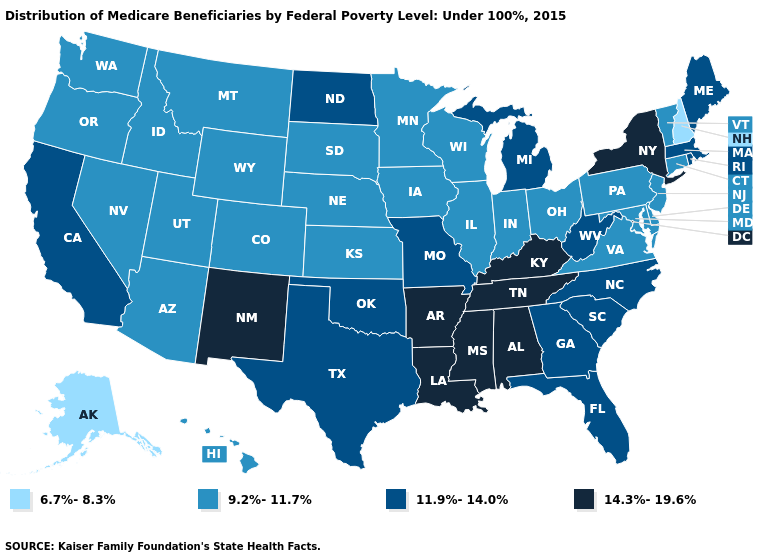What is the highest value in the Northeast ?
Quick response, please. 14.3%-19.6%. What is the lowest value in the MidWest?
Answer briefly. 9.2%-11.7%. Does New York have the highest value in the Northeast?
Short answer required. Yes. Does Michigan have a lower value than New Jersey?
Keep it brief. No. What is the value of Oregon?
Write a very short answer. 9.2%-11.7%. Name the states that have a value in the range 6.7%-8.3%?
Concise answer only. Alaska, New Hampshire. Among the states that border Ohio , which have the lowest value?
Concise answer only. Indiana, Pennsylvania. Does the map have missing data?
Give a very brief answer. No. What is the lowest value in the USA?
Concise answer only. 6.7%-8.3%. Does New Jersey have the lowest value in the Northeast?
Short answer required. No. What is the value of California?
Concise answer only. 11.9%-14.0%. What is the value of North Carolina?
Short answer required. 11.9%-14.0%. Among the states that border Pennsylvania , does Maryland have the lowest value?
Write a very short answer. Yes. How many symbols are there in the legend?
Keep it brief. 4. Name the states that have a value in the range 6.7%-8.3%?
Write a very short answer. Alaska, New Hampshire. 